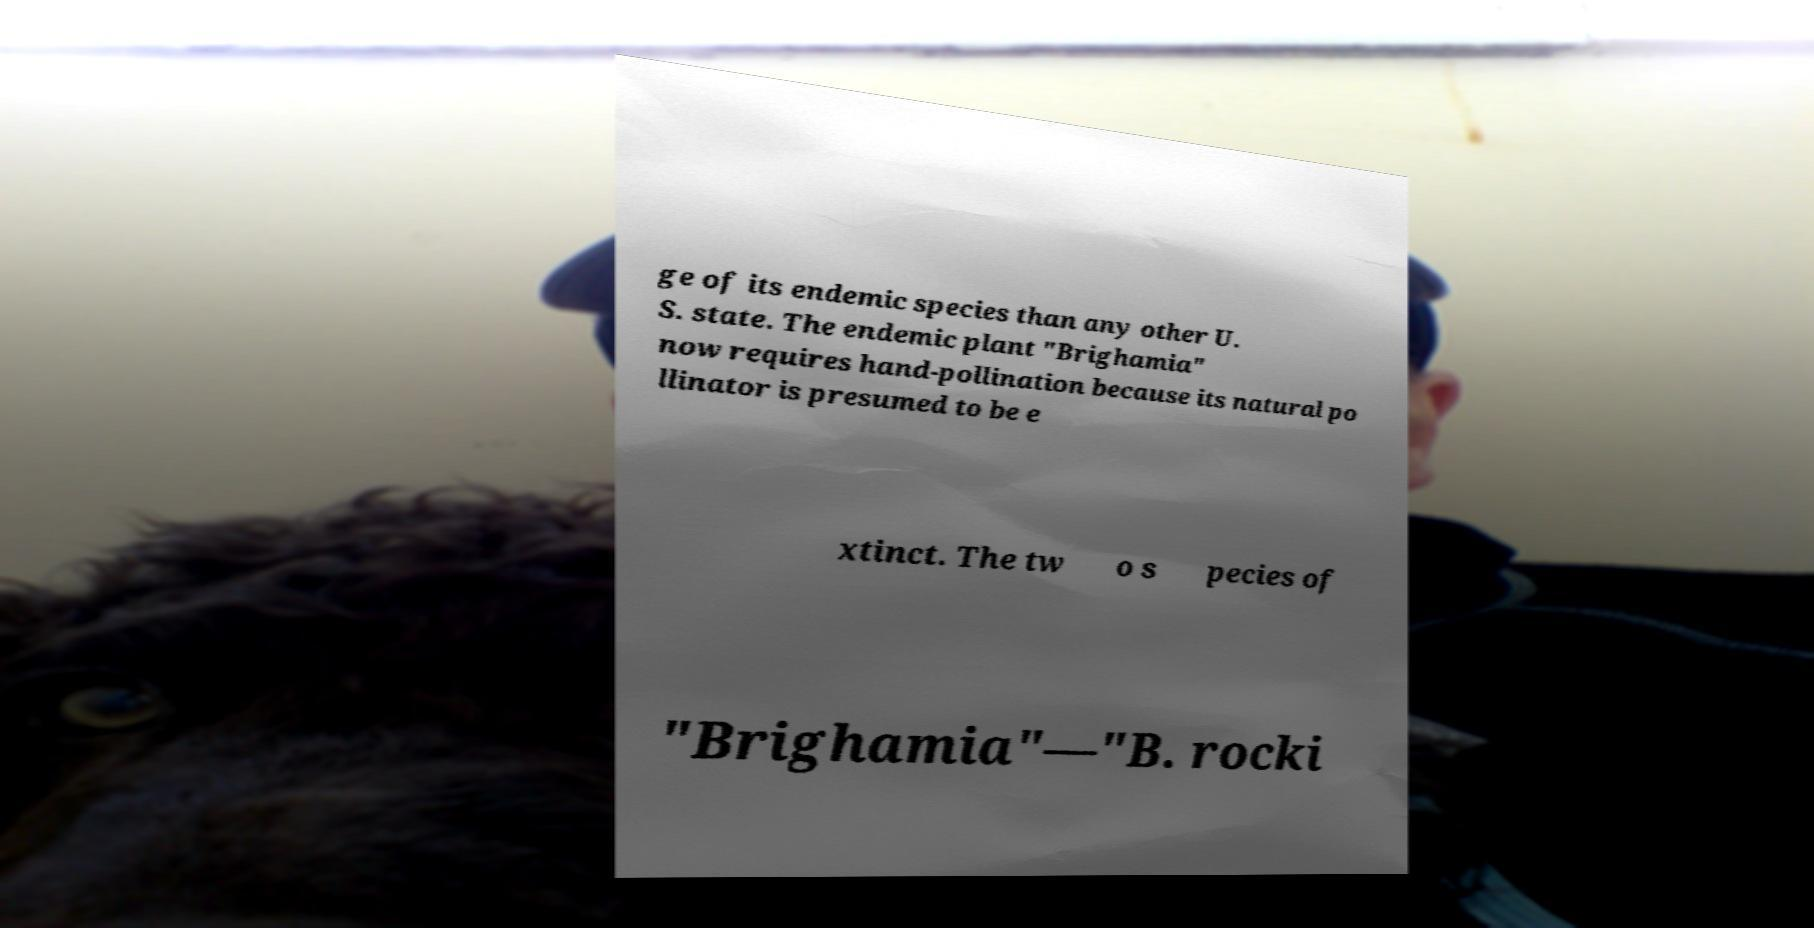What messages or text are displayed in this image? I need them in a readable, typed format. ge of its endemic species than any other U. S. state. The endemic plant "Brighamia" now requires hand-pollination because its natural po llinator is presumed to be e xtinct. The tw o s pecies of "Brighamia"—"B. rocki 